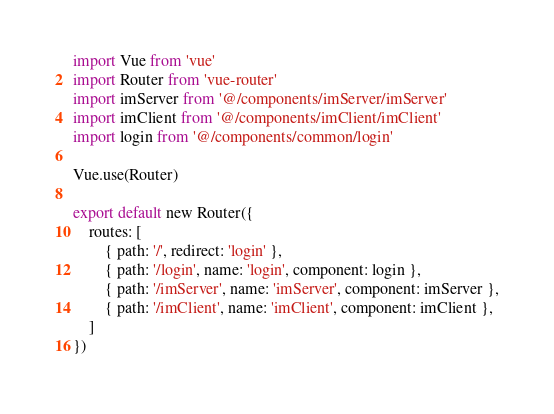<code> <loc_0><loc_0><loc_500><loc_500><_JavaScript_>import Vue from 'vue'
import Router from 'vue-router'
import imServer from '@/components/imServer/imServer'
import imClient from '@/components/imClient/imClient'
import login from '@/components/common/login'

Vue.use(Router)

export default new Router({
    routes: [
        { path: '/', redirect: 'login' },
        { path: '/login', name: 'login', component: login },
        { path: '/imServer', name: 'imServer', component: imServer },
        { path: '/imClient', name: 'imClient', component: imClient },
    ]
})
</code> 